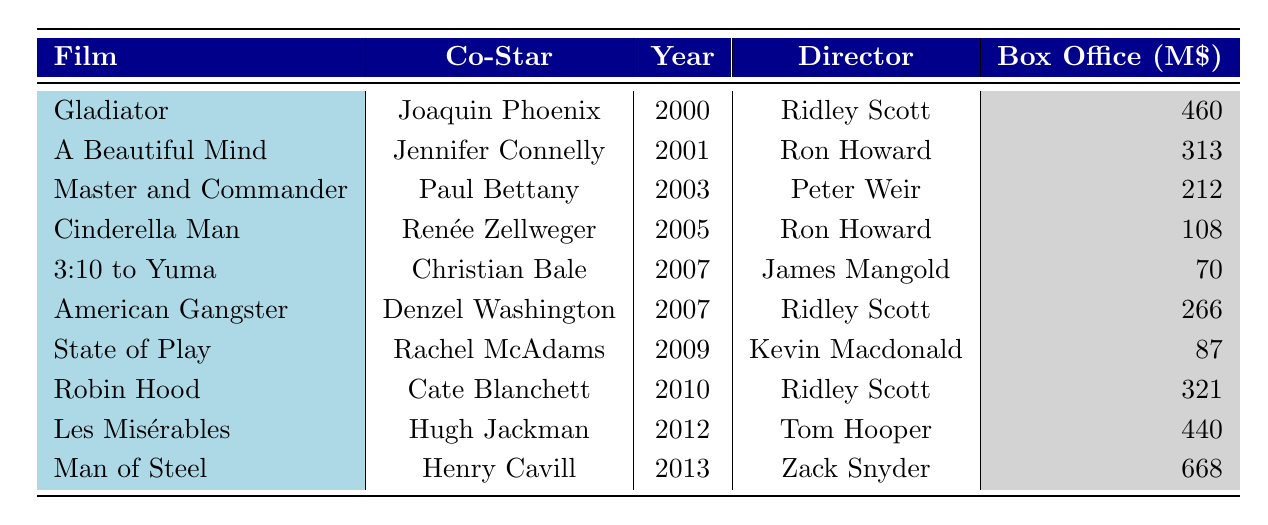What co-star appeared alongside Russell Crowe in "Gladiator"? Looking at the table, "Gladiator" is listed under the Film column and its corresponding co-star is Joaquin Phoenix.
Answer: Joaquin Phoenix Which film had the highest box office earnings? By checking the Box Office column, "Man of Steel" has the highest value at 668 million.
Answer: Man of Steel Did Russell Crowe work with Jennifer Connelly? The table indicates that Jennifer Connelly was a co-star in "A Beautiful Mind," confirming that they worked together.
Answer: Yes How many films did Russell Crowe release in the year 2007? In the table, the films "3:10 to Yuma" and "American Gangster" are both released in 2007, giving a total of 2 films.
Answer: 2 What is the average box office earnings of Russell Crowe's films directed by Ridley Scott? The relevant films directed by Ridley Scott are "Gladiator," "American Gangster," and "Robin Hood," with earnings of 460, 266, and 321 million respectively. Adding those gives 460 + 266 + 321 = 1047 million, and dividing by 3 films yields an average of 349 million.
Answer: 349 Which film has the co-star with the same last name as the director? In "Cinderella Man," the co-star Renée Zellweger has a different last name than the director Ron Howard, and similarly for other films. However, the last name for "American Gangster" shows Denzel Washington and also the director is Ridley Scott, which do not match. Hence there is no match found.
Answer: None What is the total box office of all films that Russell Crowe starred in? Summing the box office values: 460 + 313 + 212 + 108 + 70 + 266 + 87 + 321 + 440 + 668 equals 2645 million.
Answer: 2645 Which co-star has the earliest film release with Russell Crowe? In "Gladiator," released in 2000, Joaquin Phoenix is the earliest co-star listed when considering the release years.
Answer: Joaquin Phoenix What percentage of box office earnings was contributed by "Les Misérables"? The box office for "Les Misérables" is 440 million. The total box office, as calculated previously, is 2645 million. The percentage contribution is (440 / 2645) * 100 = approximately 16.64%.
Answer: 16.64% How many different directors have worked with Russell Crowe? The directors listed are Ridley Scott, Ron Howard, Peter Weir, James Mangold, Kevin Macdonald, and Tom Hooper—totally 6 unique directors.
Answer: 6 